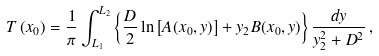<formula> <loc_0><loc_0><loc_500><loc_500>T \left ( x _ { 0 } \right ) = \frac { 1 } { \pi } \int _ { L _ { 1 } } ^ { L _ { 2 } } \left \{ \frac { D } { 2 } \ln \left [ A ( x _ { 0 } , y ) \right ] + y _ { 2 } B ( x _ { 0 } , y ) \right \} \frac { d y } { y _ { 2 } ^ { 2 } + D ^ { 2 } } \, ,</formula> 